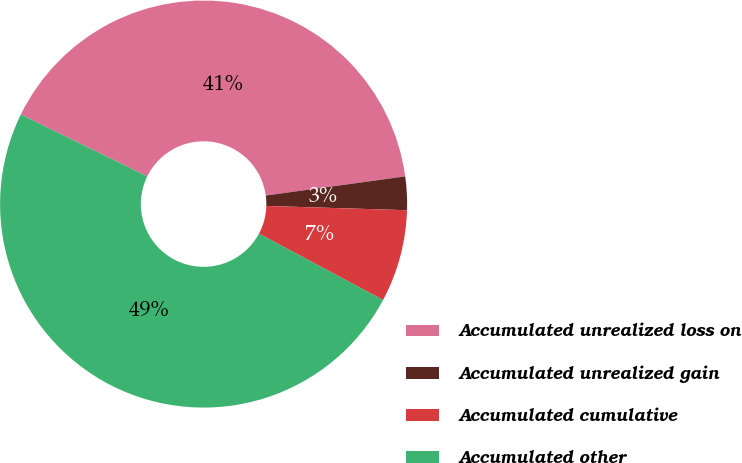Convert chart to OTSL. <chart><loc_0><loc_0><loc_500><loc_500><pie_chart><fcel>Accumulated unrealized loss on<fcel>Accumulated unrealized gain<fcel>Accumulated cumulative<fcel>Accumulated other<nl><fcel>40.57%<fcel>2.65%<fcel>7.33%<fcel>49.44%<nl></chart> 